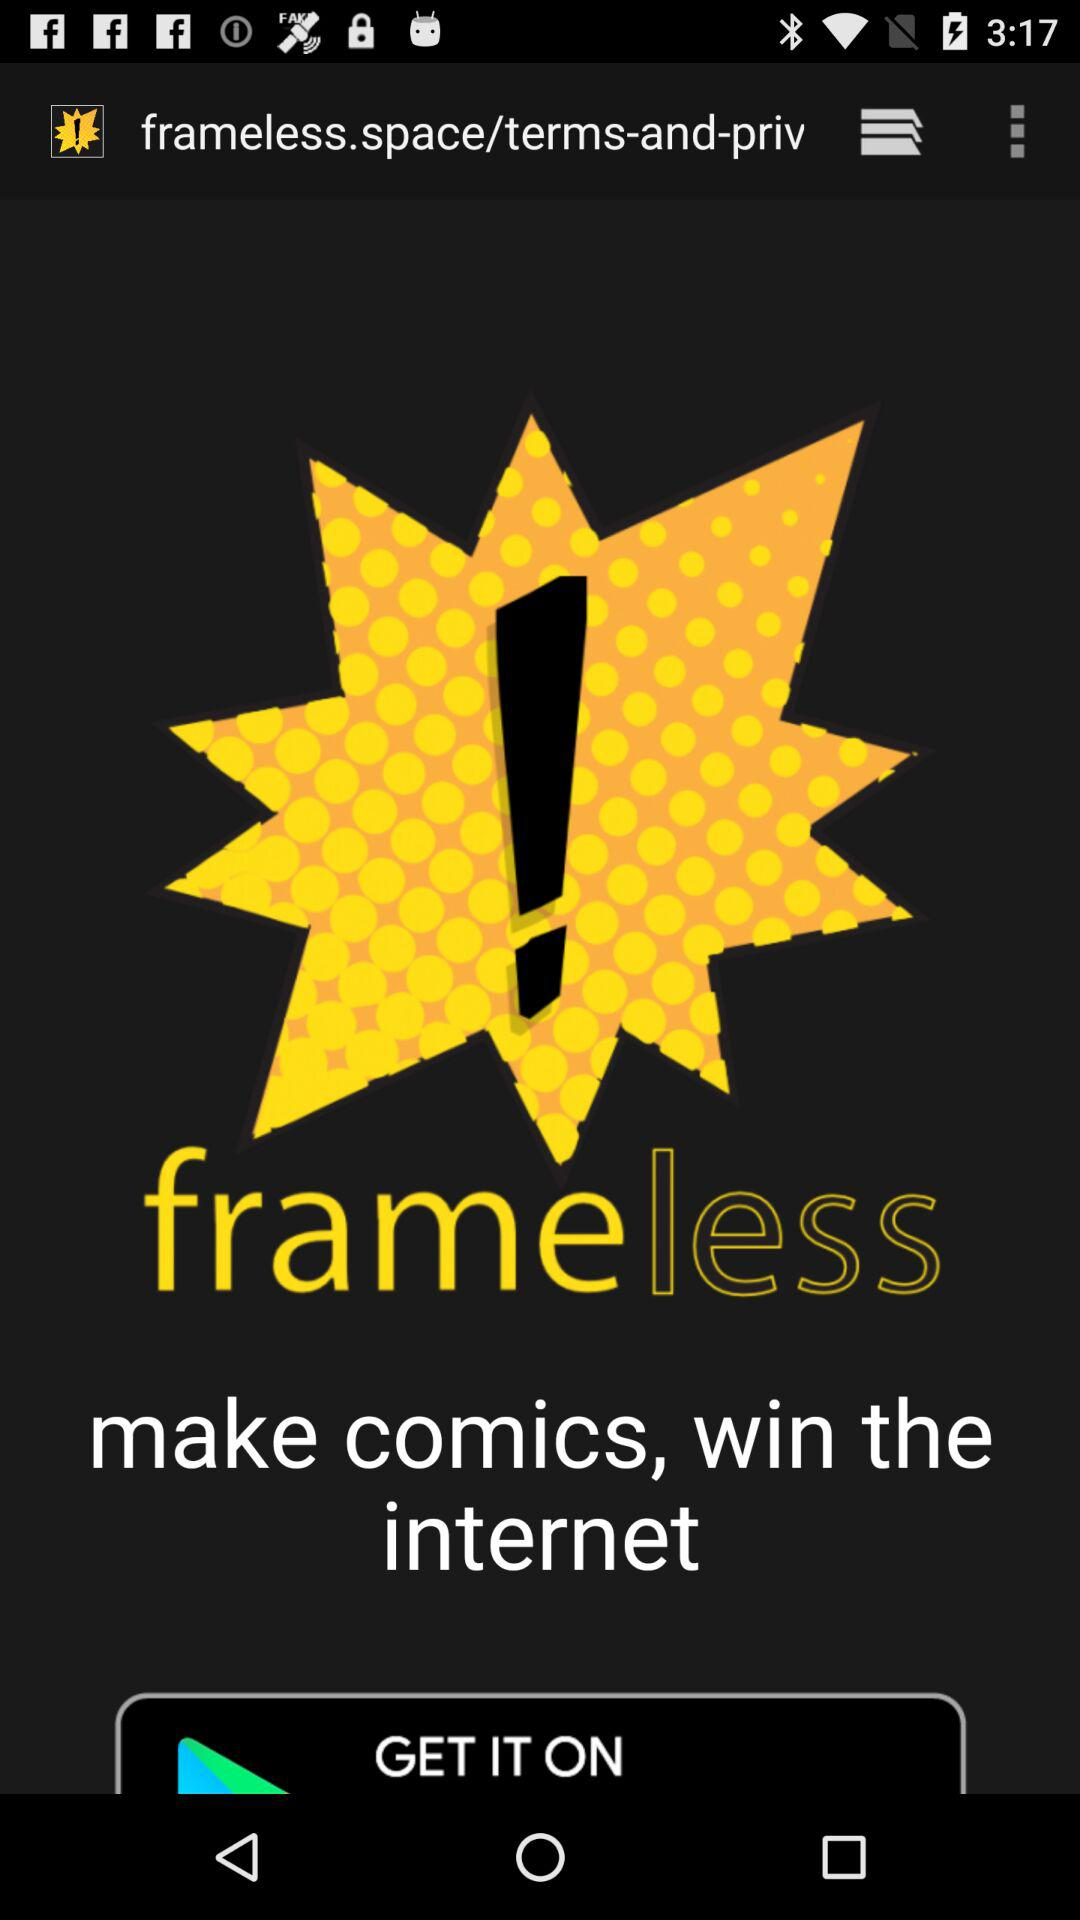What is the app name? The app name is "frameless". 